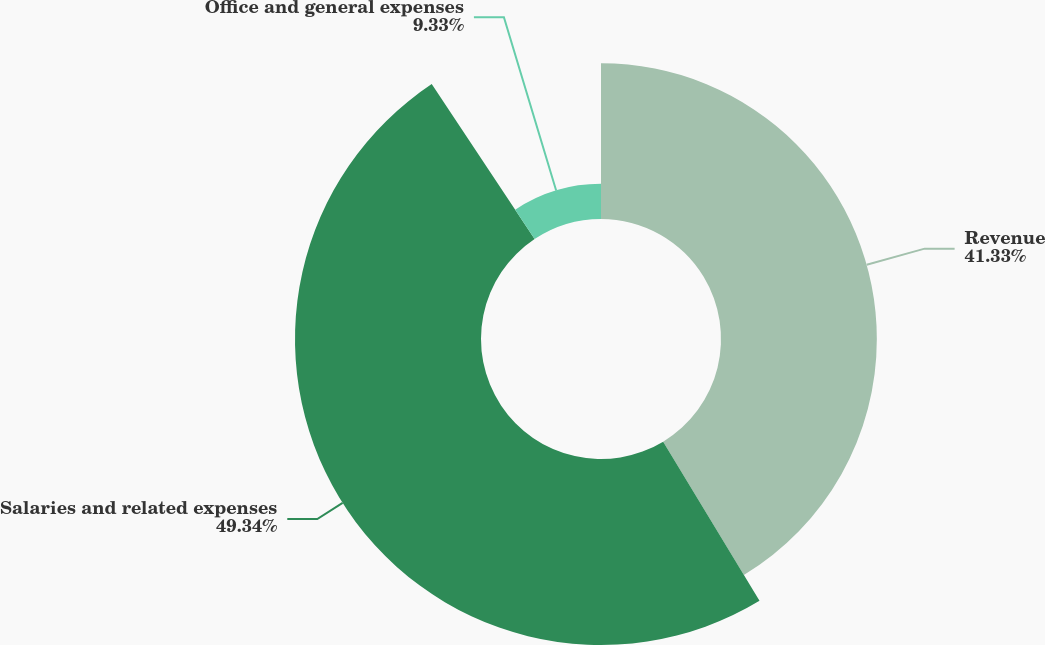Convert chart to OTSL. <chart><loc_0><loc_0><loc_500><loc_500><pie_chart><fcel>Revenue<fcel>Salaries and related expenses<fcel>Office and general expenses<nl><fcel>41.33%<fcel>49.33%<fcel>9.33%<nl></chart> 